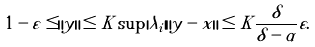<formula> <loc_0><loc_0><loc_500><loc_500>1 - \varepsilon \leq \| y \| \leq K \sup | \lambda _ { i } | \| y - x \| \leq K \frac { \delta } { \delta - \alpha } \varepsilon .</formula> 